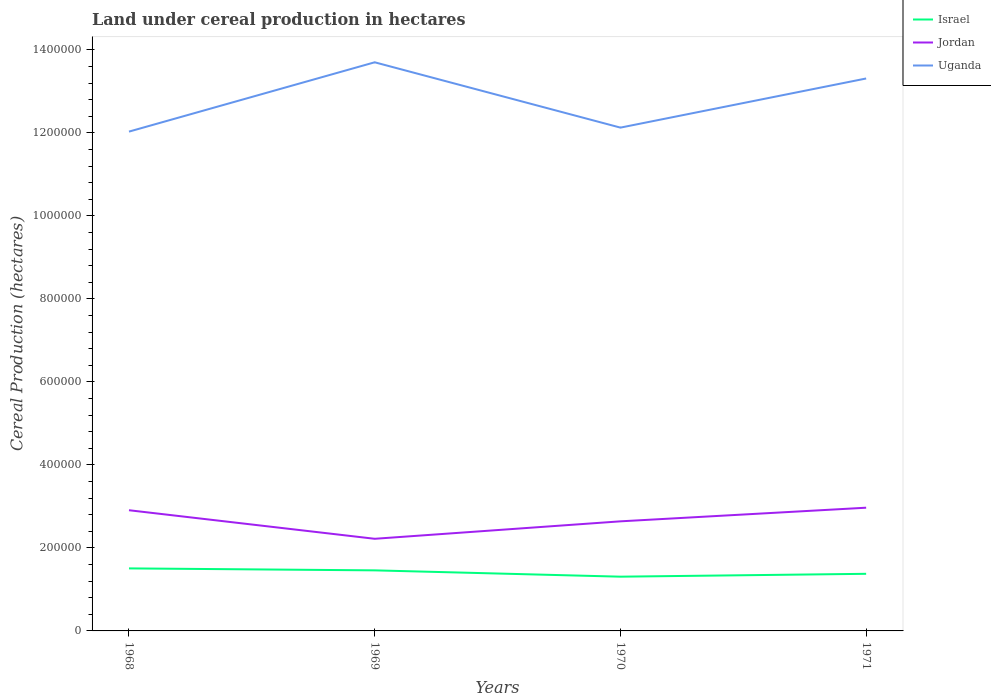Does the line corresponding to Uganda intersect with the line corresponding to Israel?
Your answer should be very brief. No. Across all years, what is the maximum land under cereal production in Uganda?
Your response must be concise. 1.20e+06. In which year was the land under cereal production in Uganda maximum?
Your response must be concise. 1968. What is the total land under cereal production in Uganda in the graph?
Keep it short and to the point. 1.57e+05. What is the difference between the highest and the second highest land under cereal production in Israel?
Ensure brevity in your answer.  1.99e+04. Is the land under cereal production in Israel strictly greater than the land under cereal production in Jordan over the years?
Keep it short and to the point. Yes. What is the difference between two consecutive major ticks on the Y-axis?
Keep it short and to the point. 2.00e+05. Are the values on the major ticks of Y-axis written in scientific E-notation?
Offer a very short reply. No. Does the graph contain any zero values?
Offer a terse response. No. Does the graph contain grids?
Your answer should be compact. No. How many legend labels are there?
Your answer should be very brief. 3. What is the title of the graph?
Make the answer very short. Land under cereal production in hectares. What is the label or title of the Y-axis?
Offer a terse response. Cereal Production (hectares). What is the Cereal Production (hectares) in Israel in 1968?
Your response must be concise. 1.51e+05. What is the Cereal Production (hectares) of Jordan in 1968?
Offer a very short reply. 2.91e+05. What is the Cereal Production (hectares) in Uganda in 1968?
Your answer should be very brief. 1.20e+06. What is the Cereal Production (hectares) in Israel in 1969?
Provide a succinct answer. 1.46e+05. What is the Cereal Production (hectares) in Jordan in 1969?
Provide a succinct answer. 2.22e+05. What is the Cereal Production (hectares) in Uganda in 1969?
Your response must be concise. 1.37e+06. What is the Cereal Production (hectares) of Israel in 1970?
Keep it short and to the point. 1.31e+05. What is the Cereal Production (hectares) of Jordan in 1970?
Your response must be concise. 2.64e+05. What is the Cereal Production (hectares) in Uganda in 1970?
Keep it short and to the point. 1.21e+06. What is the Cereal Production (hectares) of Israel in 1971?
Make the answer very short. 1.38e+05. What is the Cereal Production (hectares) in Jordan in 1971?
Your answer should be compact. 2.97e+05. What is the Cereal Production (hectares) in Uganda in 1971?
Provide a short and direct response. 1.33e+06. Across all years, what is the maximum Cereal Production (hectares) of Israel?
Keep it short and to the point. 1.51e+05. Across all years, what is the maximum Cereal Production (hectares) of Jordan?
Offer a terse response. 2.97e+05. Across all years, what is the maximum Cereal Production (hectares) in Uganda?
Offer a very short reply. 1.37e+06. Across all years, what is the minimum Cereal Production (hectares) in Israel?
Your response must be concise. 1.31e+05. Across all years, what is the minimum Cereal Production (hectares) of Jordan?
Give a very brief answer. 2.22e+05. Across all years, what is the minimum Cereal Production (hectares) in Uganda?
Keep it short and to the point. 1.20e+06. What is the total Cereal Production (hectares) of Israel in the graph?
Keep it short and to the point. 5.65e+05. What is the total Cereal Production (hectares) of Jordan in the graph?
Ensure brevity in your answer.  1.07e+06. What is the total Cereal Production (hectares) in Uganda in the graph?
Your response must be concise. 5.12e+06. What is the difference between the Cereal Production (hectares) of Israel in 1968 and that in 1969?
Your answer should be compact. 4732. What is the difference between the Cereal Production (hectares) of Jordan in 1968 and that in 1969?
Your answer should be compact. 6.88e+04. What is the difference between the Cereal Production (hectares) in Uganda in 1968 and that in 1969?
Keep it short and to the point. -1.67e+05. What is the difference between the Cereal Production (hectares) in Israel in 1968 and that in 1970?
Offer a terse response. 1.99e+04. What is the difference between the Cereal Production (hectares) in Jordan in 1968 and that in 1970?
Ensure brevity in your answer.  2.68e+04. What is the difference between the Cereal Production (hectares) of Uganda in 1968 and that in 1970?
Provide a short and direct response. -9621. What is the difference between the Cereal Production (hectares) in Israel in 1968 and that in 1971?
Keep it short and to the point. 1.31e+04. What is the difference between the Cereal Production (hectares) of Jordan in 1968 and that in 1971?
Your answer should be very brief. -6074. What is the difference between the Cereal Production (hectares) in Uganda in 1968 and that in 1971?
Provide a short and direct response. -1.28e+05. What is the difference between the Cereal Production (hectares) in Israel in 1969 and that in 1970?
Provide a succinct answer. 1.52e+04. What is the difference between the Cereal Production (hectares) of Jordan in 1969 and that in 1970?
Your response must be concise. -4.21e+04. What is the difference between the Cereal Production (hectares) in Uganda in 1969 and that in 1970?
Ensure brevity in your answer.  1.57e+05. What is the difference between the Cereal Production (hectares) of Israel in 1969 and that in 1971?
Offer a terse response. 8330. What is the difference between the Cereal Production (hectares) in Jordan in 1969 and that in 1971?
Ensure brevity in your answer.  -7.49e+04. What is the difference between the Cereal Production (hectares) in Uganda in 1969 and that in 1971?
Ensure brevity in your answer.  3.90e+04. What is the difference between the Cereal Production (hectares) in Israel in 1970 and that in 1971?
Offer a terse response. -6880. What is the difference between the Cereal Production (hectares) of Jordan in 1970 and that in 1971?
Give a very brief answer. -3.28e+04. What is the difference between the Cereal Production (hectares) in Uganda in 1970 and that in 1971?
Give a very brief answer. -1.18e+05. What is the difference between the Cereal Production (hectares) in Israel in 1968 and the Cereal Production (hectares) in Jordan in 1969?
Provide a succinct answer. -7.13e+04. What is the difference between the Cereal Production (hectares) of Israel in 1968 and the Cereal Production (hectares) of Uganda in 1969?
Make the answer very short. -1.22e+06. What is the difference between the Cereal Production (hectares) of Jordan in 1968 and the Cereal Production (hectares) of Uganda in 1969?
Your answer should be compact. -1.08e+06. What is the difference between the Cereal Production (hectares) of Israel in 1968 and the Cereal Production (hectares) of Jordan in 1970?
Provide a succinct answer. -1.13e+05. What is the difference between the Cereal Production (hectares) in Israel in 1968 and the Cereal Production (hectares) in Uganda in 1970?
Give a very brief answer. -1.06e+06. What is the difference between the Cereal Production (hectares) in Jordan in 1968 and the Cereal Production (hectares) in Uganda in 1970?
Your answer should be very brief. -9.22e+05. What is the difference between the Cereal Production (hectares) in Israel in 1968 and the Cereal Production (hectares) in Jordan in 1971?
Offer a terse response. -1.46e+05. What is the difference between the Cereal Production (hectares) in Israel in 1968 and the Cereal Production (hectares) in Uganda in 1971?
Provide a short and direct response. -1.18e+06. What is the difference between the Cereal Production (hectares) of Jordan in 1968 and the Cereal Production (hectares) of Uganda in 1971?
Your answer should be very brief. -1.04e+06. What is the difference between the Cereal Production (hectares) of Israel in 1969 and the Cereal Production (hectares) of Jordan in 1970?
Make the answer very short. -1.18e+05. What is the difference between the Cereal Production (hectares) in Israel in 1969 and the Cereal Production (hectares) in Uganda in 1970?
Provide a succinct answer. -1.07e+06. What is the difference between the Cereal Production (hectares) in Jordan in 1969 and the Cereal Production (hectares) in Uganda in 1970?
Keep it short and to the point. -9.91e+05. What is the difference between the Cereal Production (hectares) of Israel in 1969 and the Cereal Production (hectares) of Jordan in 1971?
Make the answer very short. -1.51e+05. What is the difference between the Cereal Production (hectares) of Israel in 1969 and the Cereal Production (hectares) of Uganda in 1971?
Your answer should be compact. -1.19e+06. What is the difference between the Cereal Production (hectares) of Jordan in 1969 and the Cereal Production (hectares) of Uganda in 1971?
Make the answer very short. -1.11e+06. What is the difference between the Cereal Production (hectares) in Israel in 1970 and the Cereal Production (hectares) in Jordan in 1971?
Offer a terse response. -1.66e+05. What is the difference between the Cereal Production (hectares) of Israel in 1970 and the Cereal Production (hectares) of Uganda in 1971?
Offer a terse response. -1.20e+06. What is the difference between the Cereal Production (hectares) in Jordan in 1970 and the Cereal Production (hectares) in Uganda in 1971?
Give a very brief answer. -1.07e+06. What is the average Cereal Production (hectares) in Israel per year?
Provide a short and direct response. 1.41e+05. What is the average Cereal Production (hectares) in Jordan per year?
Make the answer very short. 2.68e+05. What is the average Cereal Production (hectares) of Uganda per year?
Make the answer very short. 1.28e+06. In the year 1968, what is the difference between the Cereal Production (hectares) of Israel and Cereal Production (hectares) of Jordan?
Make the answer very short. -1.40e+05. In the year 1968, what is the difference between the Cereal Production (hectares) of Israel and Cereal Production (hectares) of Uganda?
Your answer should be compact. -1.05e+06. In the year 1968, what is the difference between the Cereal Production (hectares) in Jordan and Cereal Production (hectares) in Uganda?
Provide a short and direct response. -9.12e+05. In the year 1969, what is the difference between the Cereal Production (hectares) of Israel and Cereal Production (hectares) of Jordan?
Your answer should be very brief. -7.61e+04. In the year 1969, what is the difference between the Cereal Production (hectares) in Israel and Cereal Production (hectares) in Uganda?
Offer a terse response. -1.22e+06. In the year 1969, what is the difference between the Cereal Production (hectares) in Jordan and Cereal Production (hectares) in Uganda?
Your answer should be very brief. -1.15e+06. In the year 1970, what is the difference between the Cereal Production (hectares) in Israel and Cereal Production (hectares) in Jordan?
Make the answer very short. -1.33e+05. In the year 1970, what is the difference between the Cereal Production (hectares) of Israel and Cereal Production (hectares) of Uganda?
Your answer should be compact. -1.08e+06. In the year 1970, what is the difference between the Cereal Production (hectares) of Jordan and Cereal Production (hectares) of Uganda?
Provide a short and direct response. -9.49e+05. In the year 1971, what is the difference between the Cereal Production (hectares) of Israel and Cereal Production (hectares) of Jordan?
Ensure brevity in your answer.  -1.59e+05. In the year 1971, what is the difference between the Cereal Production (hectares) of Israel and Cereal Production (hectares) of Uganda?
Your answer should be compact. -1.19e+06. In the year 1971, what is the difference between the Cereal Production (hectares) of Jordan and Cereal Production (hectares) of Uganda?
Offer a very short reply. -1.03e+06. What is the ratio of the Cereal Production (hectares) of Israel in 1968 to that in 1969?
Offer a terse response. 1.03. What is the ratio of the Cereal Production (hectares) in Jordan in 1968 to that in 1969?
Give a very brief answer. 1.31. What is the ratio of the Cereal Production (hectares) of Uganda in 1968 to that in 1969?
Provide a short and direct response. 0.88. What is the ratio of the Cereal Production (hectares) in Israel in 1968 to that in 1970?
Offer a terse response. 1.15. What is the ratio of the Cereal Production (hectares) of Jordan in 1968 to that in 1970?
Ensure brevity in your answer.  1.1. What is the ratio of the Cereal Production (hectares) in Uganda in 1968 to that in 1970?
Offer a very short reply. 0.99. What is the ratio of the Cereal Production (hectares) of Israel in 1968 to that in 1971?
Give a very brief answer. 1.09. What is the ratio of the Cereal Production (hectares) of Jordan in 1968 to that in 1971?
Your response must be concise. 0.98. What is the ratio of the Cereal Production (hectares) of Uganda in 1968 to that in 1971?
Give a very brief answer. 0.9. What is the ratio of the Cereal Production (hectares) in Israel in 1969 to that in 1970?
Your answer should be very brief. 1.12. What is the ratio of the Cereal Production (hectares) in Jordan in 1969 to that in 1970?
Provide a short and direct response. 0.84. What is the ratio of the Cereal Production (hectares) in Uganda in 1969 to that in 1970?
Make the answer very short. 1.13. What is the ratio of the Cereal Production (hectares) of Israel in 1969 to that in 1971?
Offer a very short reply. 1.06. What is the ratio of the Cereal Production (hectares) in Jordan in 1969 to that in 1971?
Provide a succinct answer. 0.75. What is the ratio of the Cereal Production (hectares) of Uganda in 1969 to that in 1971?
Ensure brevity in your answer.  1.03. What is the ratio of the Cereal Production (hectares) in Jordan in 1970 to that in 1971?
Your response must be concise. 0.89. What is the ratio of the Cereal Production (hectares) of Uganda in 1970 to that in 1971?
Provide a succinct answer. 0.91. What is the difference between the highest and the second highest Cereal Production (hectares) of Israel?
Your answer should be compact. 4732. What is the difference between the highest and the second highest Cereal Production (hectares) of Jordan?
Provide a short and direct response. 6074. What is the difference between the highest and the second highest Cereal Production (hectares) in Uganda?
Your answer should be very brief. 3.90e+04. What is the difference between the highest and the lowest Cereal Production (hectares) in Israel?
Make the answer very short. 1.99e+04. What is the difference between the highest and the lowest Cereal Production (hectares) in Jordan?
Provide a short and direct response. 7.49e+04. What is the difference between the highest and the lowest Cereal Production (hectares) of Uganda?
Give a very brief answer. 1.67e+05. 